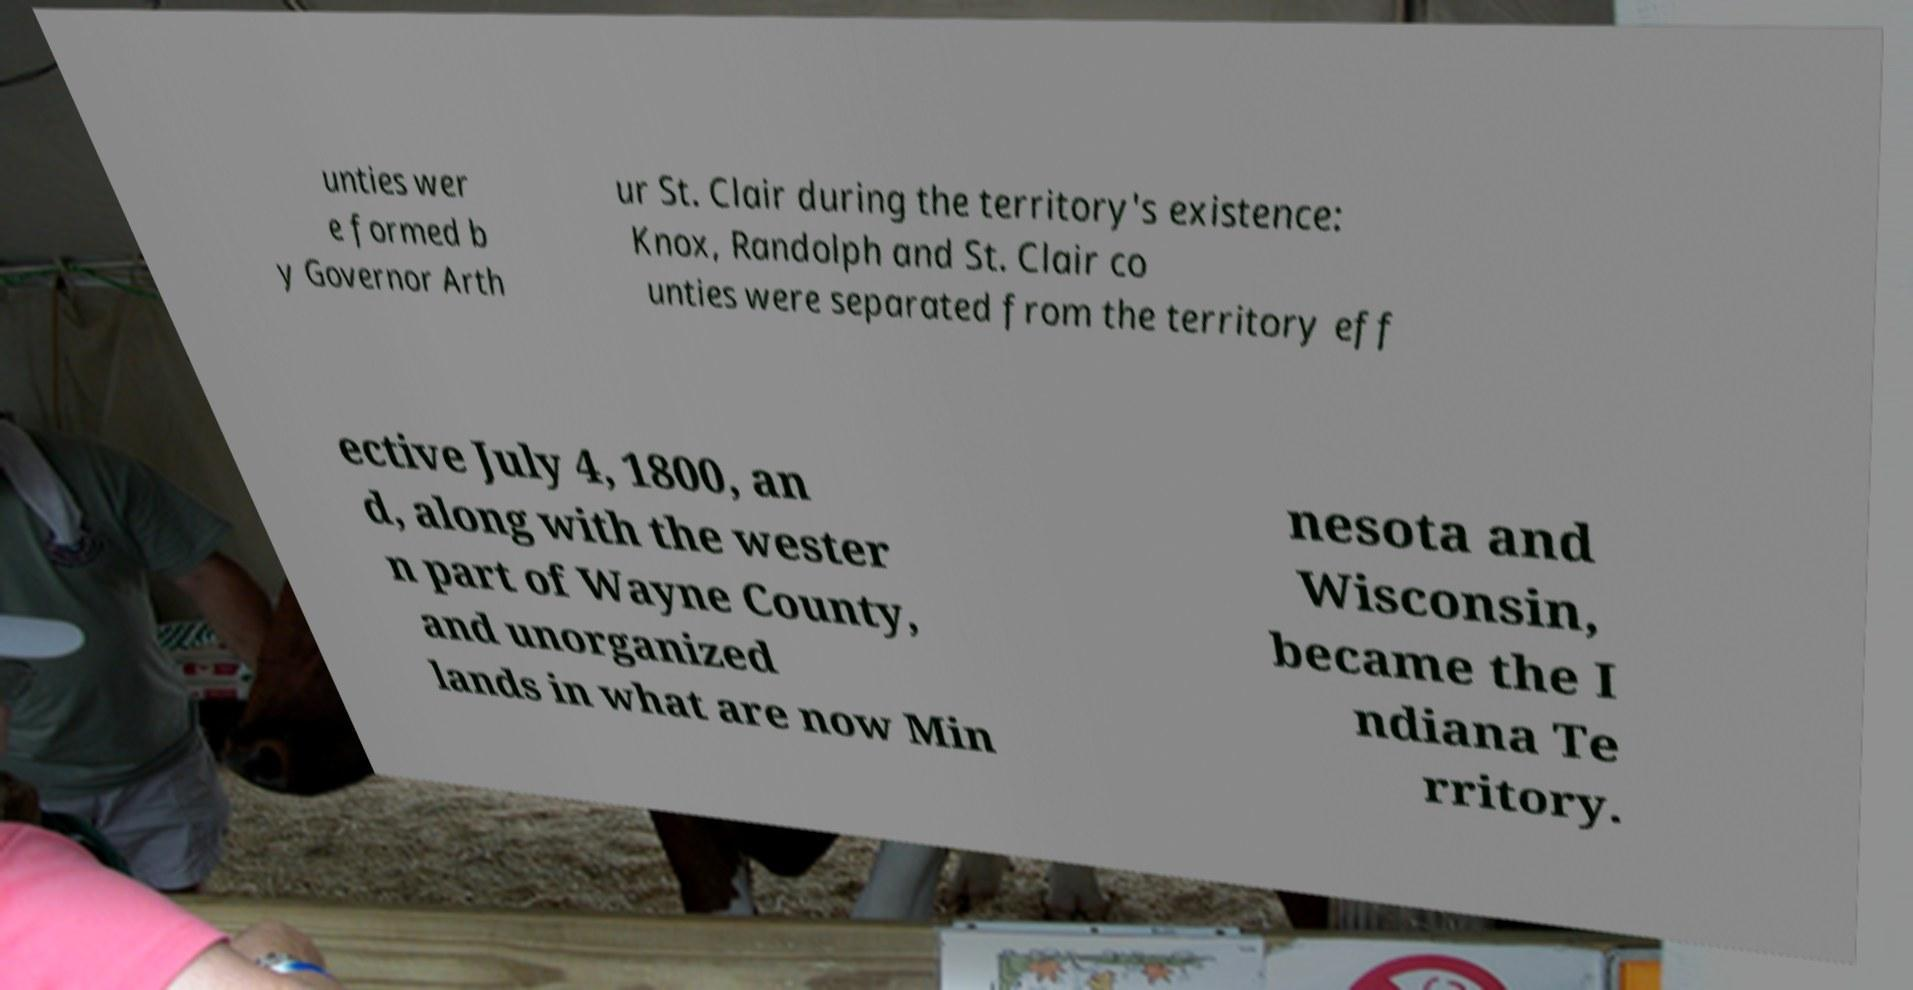Please read and relay the text visible in this image. What does it say? unties wer e formed b y Governor Arth ur St. Clair during the territory's existence: Knox, Randolph and St. Clair co unties were separated from the territory eff ective July 4, 1800, an d, along with the wester n part of Wayne County, and unorganized lands in what are now Min nesota and Wisconsin, became the I ndiana Te rritory. 